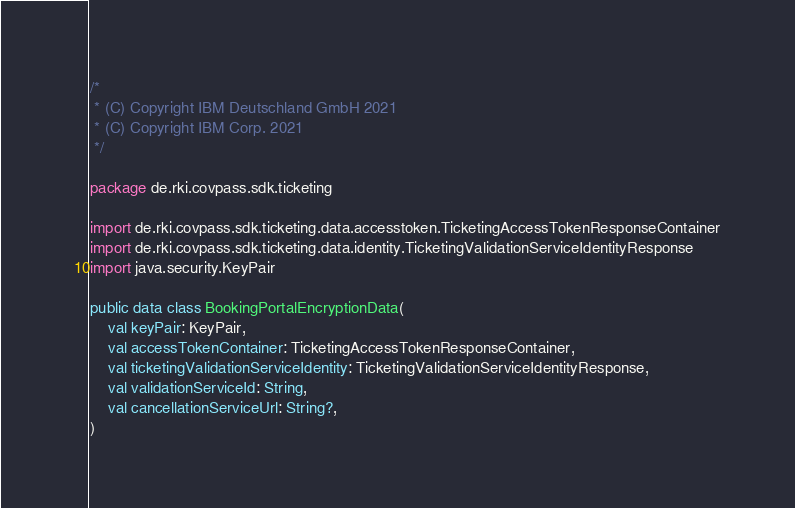Convert code to text. <code><loc_0><loc_0><loc_500><loc_500><_Kotlin_>/*
 * (C) Copyright IBM Deutschland GmbH 2021
 * (C) Copyright IBM Corp. 2021
 */

package de.rki.covpass.sdk.ticketing

import de.rki.covpass.sdk.ticketing.data.accesstoken.TicketingAccessTokenResponseContainer
import de.rki.covpass.sdk.ticketing.data.identity.TicketingValidationServiceIdentityResponse
import java.security.KeyPair

public data class BookingPortalEncryptionData(
    val keyPair: KeyPair,
    val accessTokenContainer: TicketingAccessTokenResponseContainer,
    val ticketingValidationServiceIdentity: TicketingValidationServiceIdentityResponse,
    val validationServiceId: String,
    val cancellationServiceUrl: String?,
)
</code> 